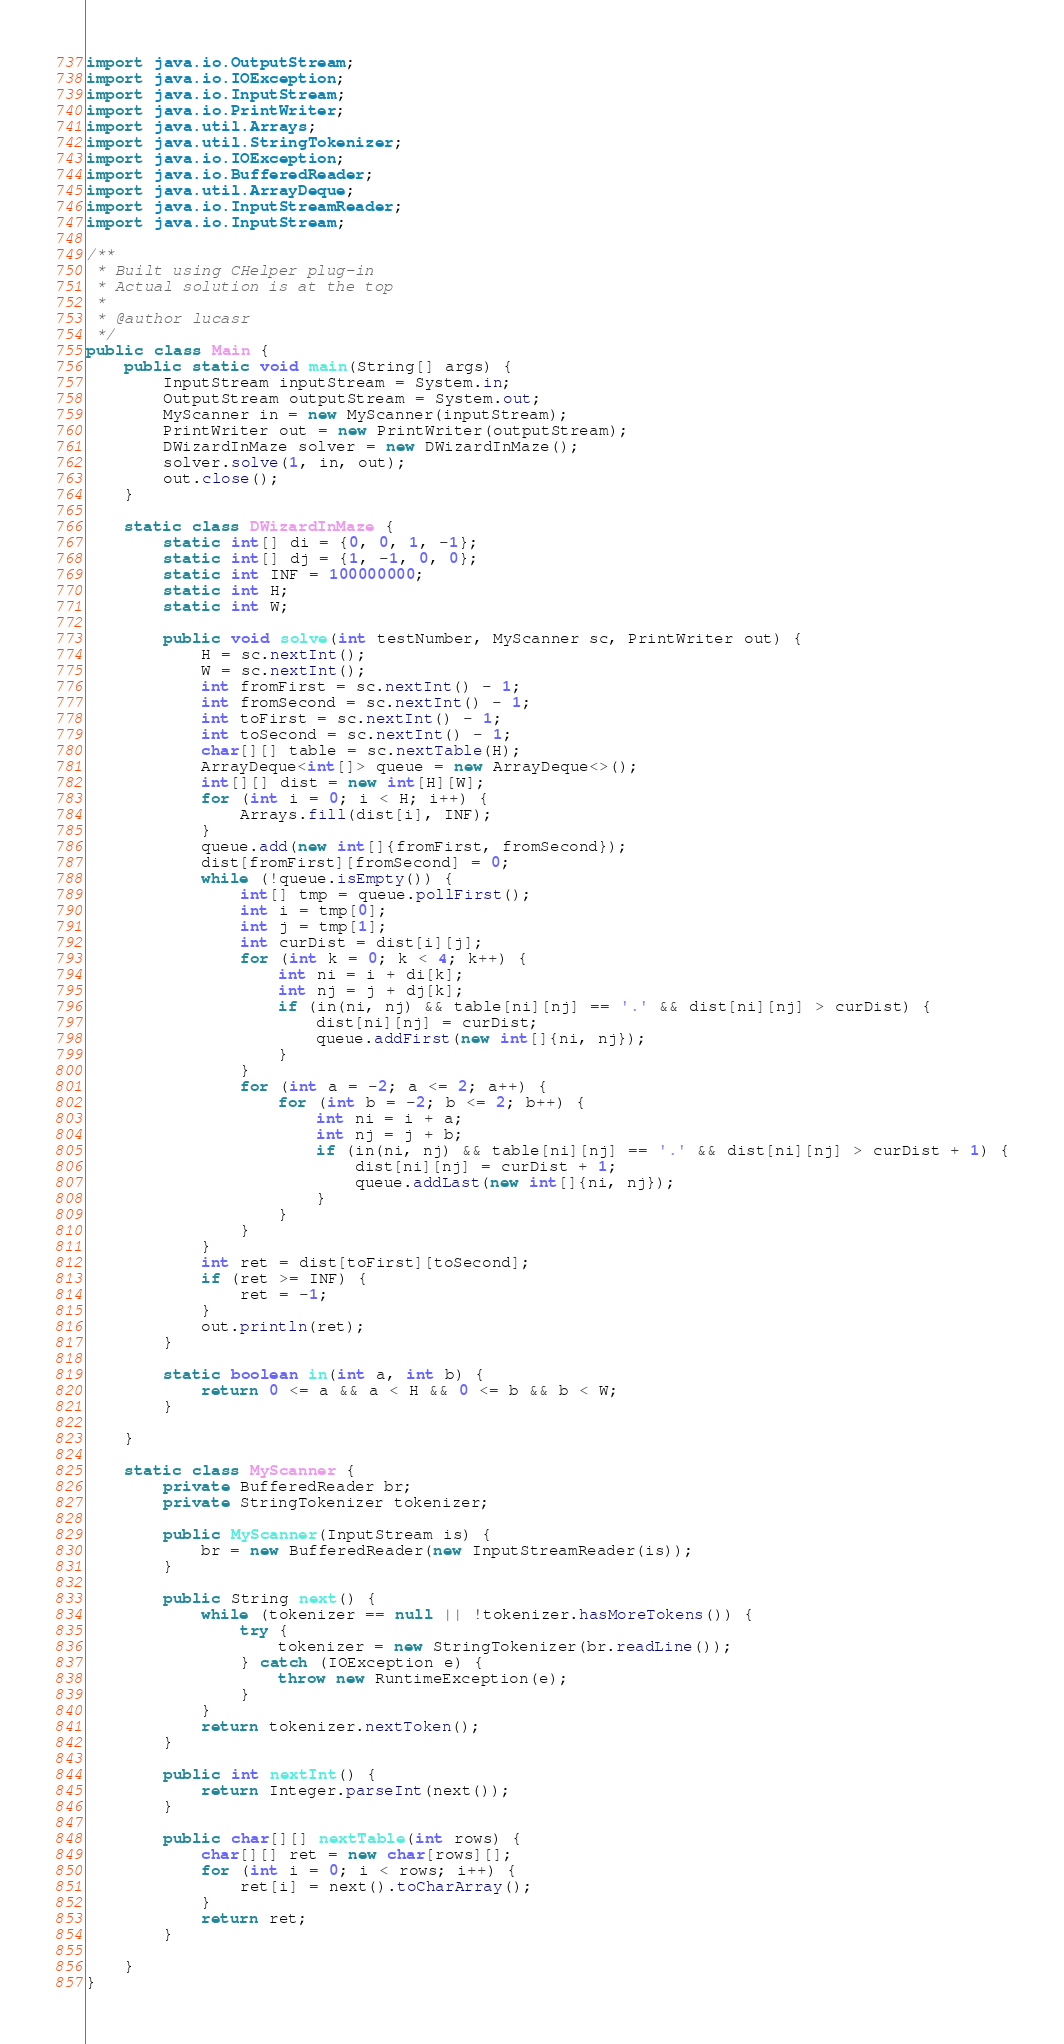Convert code to text. <code><loc_0><loc_0><loc_500><loc_500><_Java_>import java.io.OutputStream;
import java.io.IOException;
import java.io.InputStream;
import java.io.PrintWriter;
import java.util.Arrays;
import java.util.StringTokenizer;
import java.io.IOException;
import java.io.BufferedReader;
import java.util.ArrayDeque;
import java.io.InputStreamReader;
import java.io.InputStream;

/**
 * Built using CHelper plug-in
 * Actual solution is at the top
 *
 * @author lucasr
 */
public class Main {
    public static void main(String[] args) {
        InputStream inputStream = System.in;
        OutputStream outputStream = System.out;
        MyScanner in = new MyScanner(inputStream);
        PrintWriter out = new PrintWriter(outputStream);
        DWizardInMaze solver = new DWizardInMaze();
        solver.solve(1, in, out);
        out.close();
    }

    static class DWizardInMaze {
        static int[] di = {0, 0, 1, -1};
        static int[] dj = {1, -1, 0, 0};
        static int INF = 100000000;
        static int H;
        static int W;

        public void solve(int testNumber, MyScanner sc, PrintWriter out) {
            H = sc.nextInt();
            W = sc.nextInt();
            int fromFirst = sc.nextInt() - 1;
            int fromSecond = sc.nextInt() - 1;
            int toFirst = sc.nextInt() - 1;
            int toSecond = sc.nextInt() - 1;
            char[][] table = sc.nextTable(H);
            ArrayDeque<int[]> queue = new ArrayDeque<>();
            int[][] dist = new int[H][W];
            for (int i = 0; i < H; i++) {
                Arrays.fill(dist[i], INF);
            }
            queue.add(new int[]{fromFirst, fromSecond});
            dist[fromFirst][fromSecond] = 0;
            while (!queue.isEmpty()) {
                int[] tmp = queue.pollFirst();
                int i = tmp[0];
                int j = tmp[1];
                int curDist = dist[i][j];
                for (int k = 0; k < 4; k++) {
                    int ni = i + di[k];
                    int nj = j + dj[k];
                    if (in(ni, nj) && table[ni][nj] == '.' && dist[ni][nj] > curDist) {
                        dist[ni][nj] = curDist;
                        queue.addFirst(new int[]{ni, nj});
                    }
                }
                for (int a = -2; a <= 2; a++) {
                    for (int b = -2; b <= 2; b++) {
                        int ni = i + a;
                        int nj = j + b;
                        if (in(ni, nj) && table[ni][nj] == '.' && dist[ni][nj] > curDist + 1) {
                            dist[ni][nj] = curDist + 1;
                            queue.addLast(new int[]{ni, nj});
                        }
                    }
                }
            }
            int ret = dist[toFirst][toSecond];
            if (ret >= INF) {
                ret = -1;
            }
            out.println(ret);
        }

        static boolean in(int a, int b) {
            return 0 <= a && a < H && 0 <= b && b < W;
        }

    }

    static class MyScanner {
        private BufferedReader br;
        private StringTokenizer tokenizer;

        public MyScanner(InputStream is) {
            br = new BufferedReader(new InputStreamReader(is));
        }

        public String next() {
            while (tokenizer == null || !tokenizer.hasMoreTokens()) {
                try {
                    tokenizer = new StringTokenizer(br.readLine());
                } catch (IOException e) {
                    throw new RuntimeException(e);
                }
            }
            return tokenizer.nextToken();
        }

        public int nextInt() {
            return Integer.parseInt(next());
        }

        public char[][] nextTable(int rows) {
            char[][] ret = new char[rows][];
            for (int i = 0; i < rows; i++) {
                ret[i] = next().toCharArray();
            }
            return ret;
        }

    }
}

</code> 